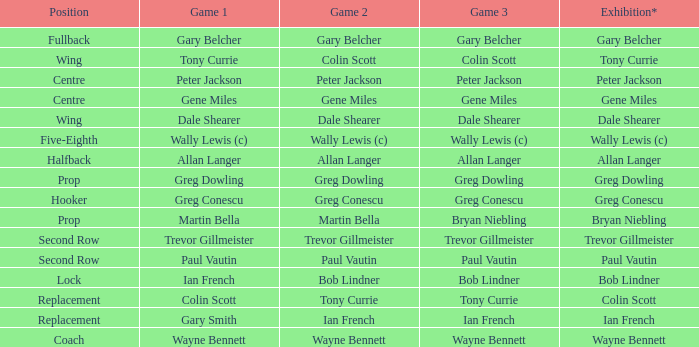In what game does bob lindner have a comparable position to his role in game 2? Ian French. 